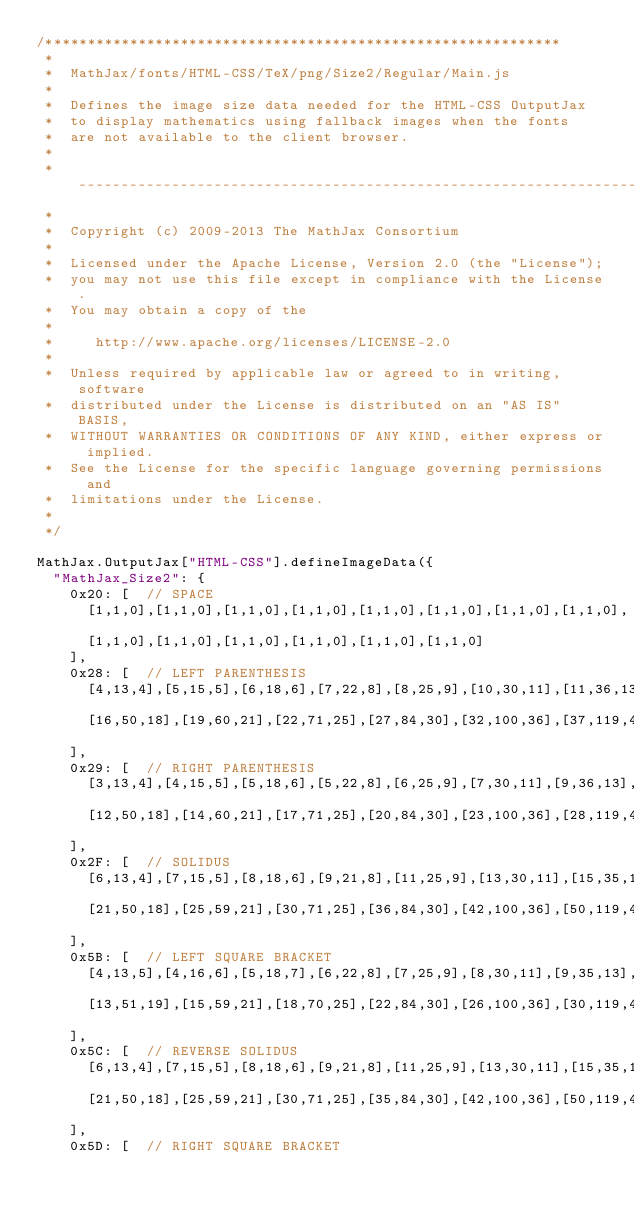<code> <loc_0><loc_0><loc_500><loc_500><_JavaScript_>/*************************************************************
 *
 *  MathJax/fonts/HTML-CSS/TeX/png/Size2/Regular/Main.js
 *  
 *  Defines the image size data needed for the HTML-CSS OutputJax
 *  to display mathematics using fallback images when the fonts
 *  are not available to the client browser.
 *
 *  ---------------------------------------------------------------------
 *
 *  Copyright (c) 2009-2013 The MathJax Consortium
 *
 *  Licensed under the Apache License, Version 2.0 (the "License");
 *  you may not use this file except in compliance with the License.
 *  You may obtain a copy of the
 *
 *     http://www.apache.org/licenses/LICENSE-2.0
 *
 *  Unless required by applicable law or agreed to in writing, software
 *  distributed under the License is distributed on an "AS IS" BASIS,
 *  WITHOUT WARRANTIES OR CONDITIONS OF ANY KIND, either express or implied.
 *  See the License for the specific language governing permissions and
 *  limitations under the License.
 *
 */

MathJax.OutputJax["HTML-CSS"].defineImageData({
  "MathJax_Size2": {
    0x20: [  // SPACE
      [1,1,0],[1,1,0],[1,1,0],[1,1,0],[1,1,0],[1,1,0],[1,1,0],[1,1,0],
      [1,1,0],[1,1,0],[1,1,0],[1,1,0],[1,1,0],[1,1,0]
    ],
    0x28: [  // LEFT PARENTHESIS
      [4,13,4],[5,15,5],[6,18,6],[7,22,8],[8,25,9],[10,30,11],[11,36,13],[14,42,15],
      [16,50,18],[19,60,21],[22,71,25],[27,84,30],[32,100,36],[37,119,43]
    ],
    0x29: [  // RIGHT PARENTHESIS
      [3,13,4],[4,15,5],[5,18,6],[5,22,8],[6,25,9],[7,30,11],[9,36,13],[10,42,15],
      [12,50,18],[14,60,21],[17,71,25],[20,84,30],[23,100,36],[28,119,43]
    ],
    0x2F: [  // SOLIDUS
      [6,13,4],[7,15,5],[8,18,6],[9,21,8],[11,25,9],[13,30,11],[15,35,13],[18,42,15],
      [21,50,18],[25,59,21],[30,71,25],[36,84,30],[42,100,36],[50,119,43]
    ],
    0x5B: [  // LEFT SQUARE BRACKET
      [4,13,5],[4,16,6],[5,18,7],[6,22,8],[7,25,9],[8,30,11],[9,35,13],[11,43,16],
      [13,51,19],[15,59,21],[18,70,25],[22,84,30],[26,100,36],[30,119,43]
    ],
    0x5C: [  // REVERSE SOLIDUS
      [6,13,4],[7,15,5],[8,18,6],[9,21,8],[11,25,9],[13,30,11],[15,35,13],[18,42,15],
      [21,50,18],[25,59,21],[30,71,25],[35,84,30],[42,100,36],[50,119,43]
    ],
    0x5D: [  // RIGHT SQUARE BRACKET</code> 